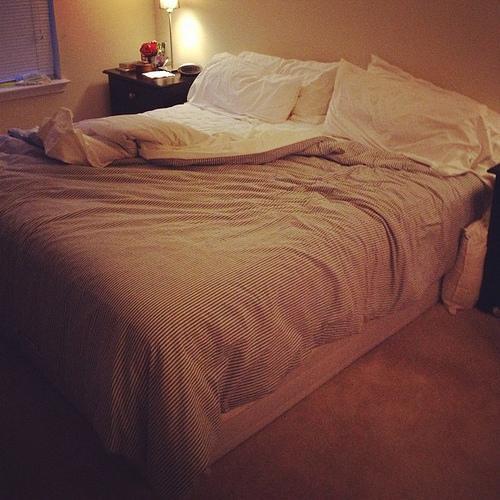How many beds are there?
Give a very brief answer. 1. 